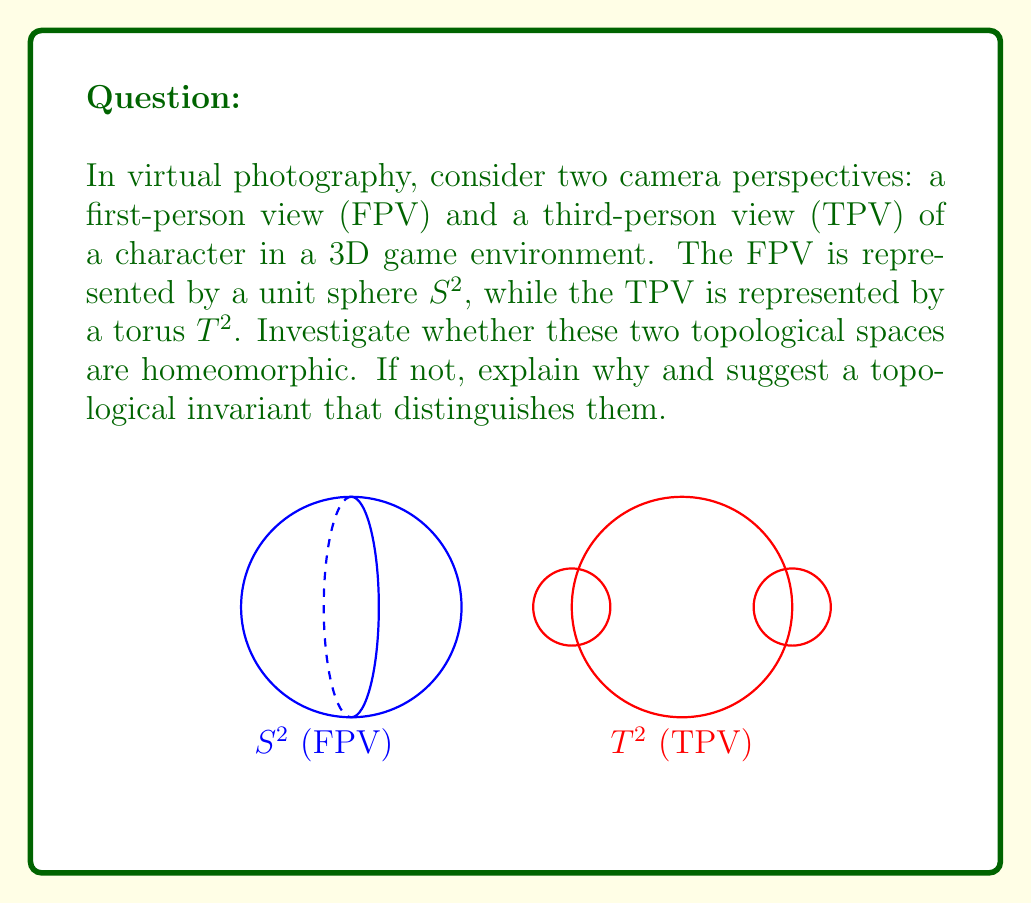Can you solve this math problem? To determine if the unit sphere $S^2$ (representing FPV) and the torus $T^2$ (representing TPV) are homeomorphic, we need to investigate their topological properties:

1. Definition of homeomorphism:
   Two topological spaces are homeomorphic if there exists a continuous bijective function between them with a continuous inverse.

2. Fundamental groups:
   - For $S^2$: $\pi_1(S^2) \cong \{e\}$ (trivial group)
   - For $T^2$: $\pi_1(T^2) \cong \mathbb{Z} \times \mathbb{Z}$ (free abelian group of rank 2)

3. Euler characteristic:
   - For $S^2$: $\chi(S^2) = 2$
   - For $T^2$: $\chi(T^2) = 0$

4. Genus:
   - For $S^2$: $g(S^2) = 0$
   - For $T^2$: $g(T^2) = 1$

5. Conclusion:
   $S^2$ and $T^2$ are not homeomorphic because they have different fundamental groups, Euler characteristics, and genera. These are topological invariants that distinguish the two spaces.

6. Topological invariant:
   The fundamental group is a suitable topological invariant to distinguish $S^2$ and $T^2$. It captures the essential difference in their "hole" structure: $S^2$ has no holes, while $T^2$ has one hole.
Answer: Not homeomorphic; fundamental group distinguishes them: $\pi_1(S^2) \cong \{e\}$, $\pi_1(T^2) \cong \mathbb{Z} \times \mathbb{Z}$. 